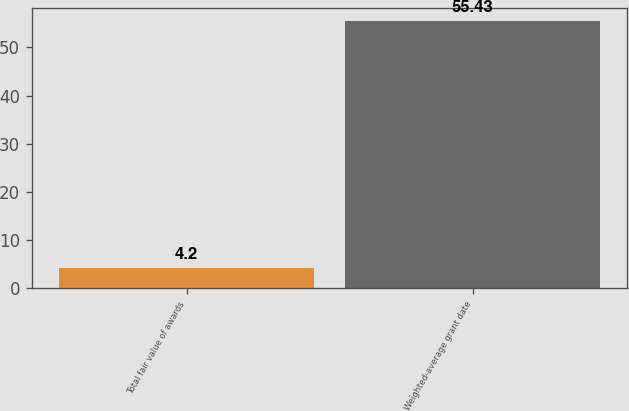Convert chart. <chart><loc_0><loc_0><loc_500><loc_500><bar_chart><fcel>Total fair value of awards<fcel>Weighted-average grant date<nl><fcel>4.2<fcel>55.43<nl></chart> 